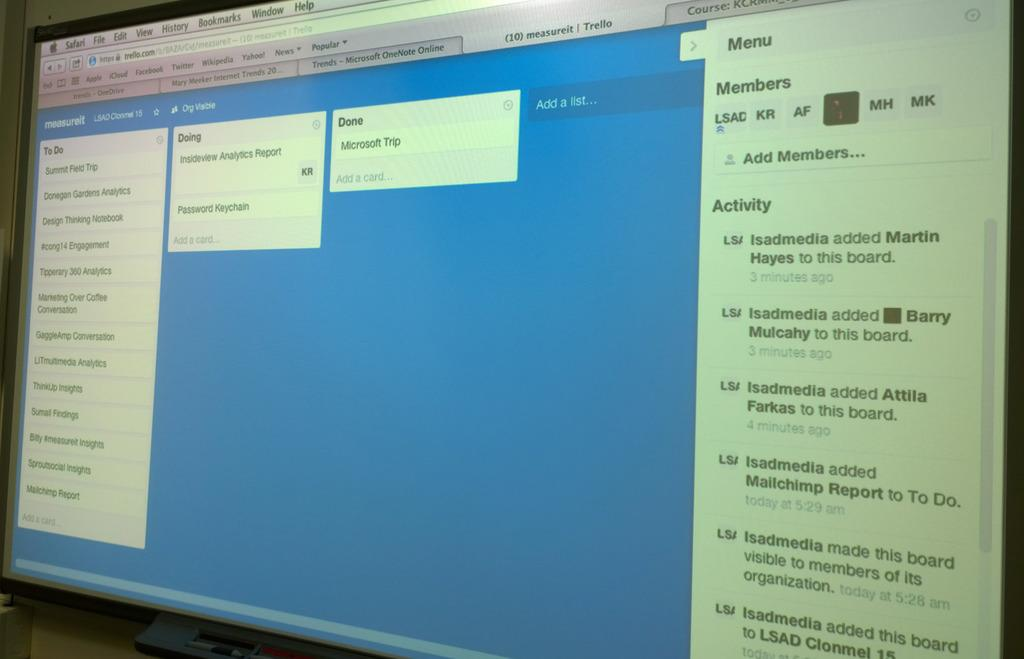<image>
Create a compact narrative representing the image presented. A computer monitor has the windows open that say to do, doing, and done. 